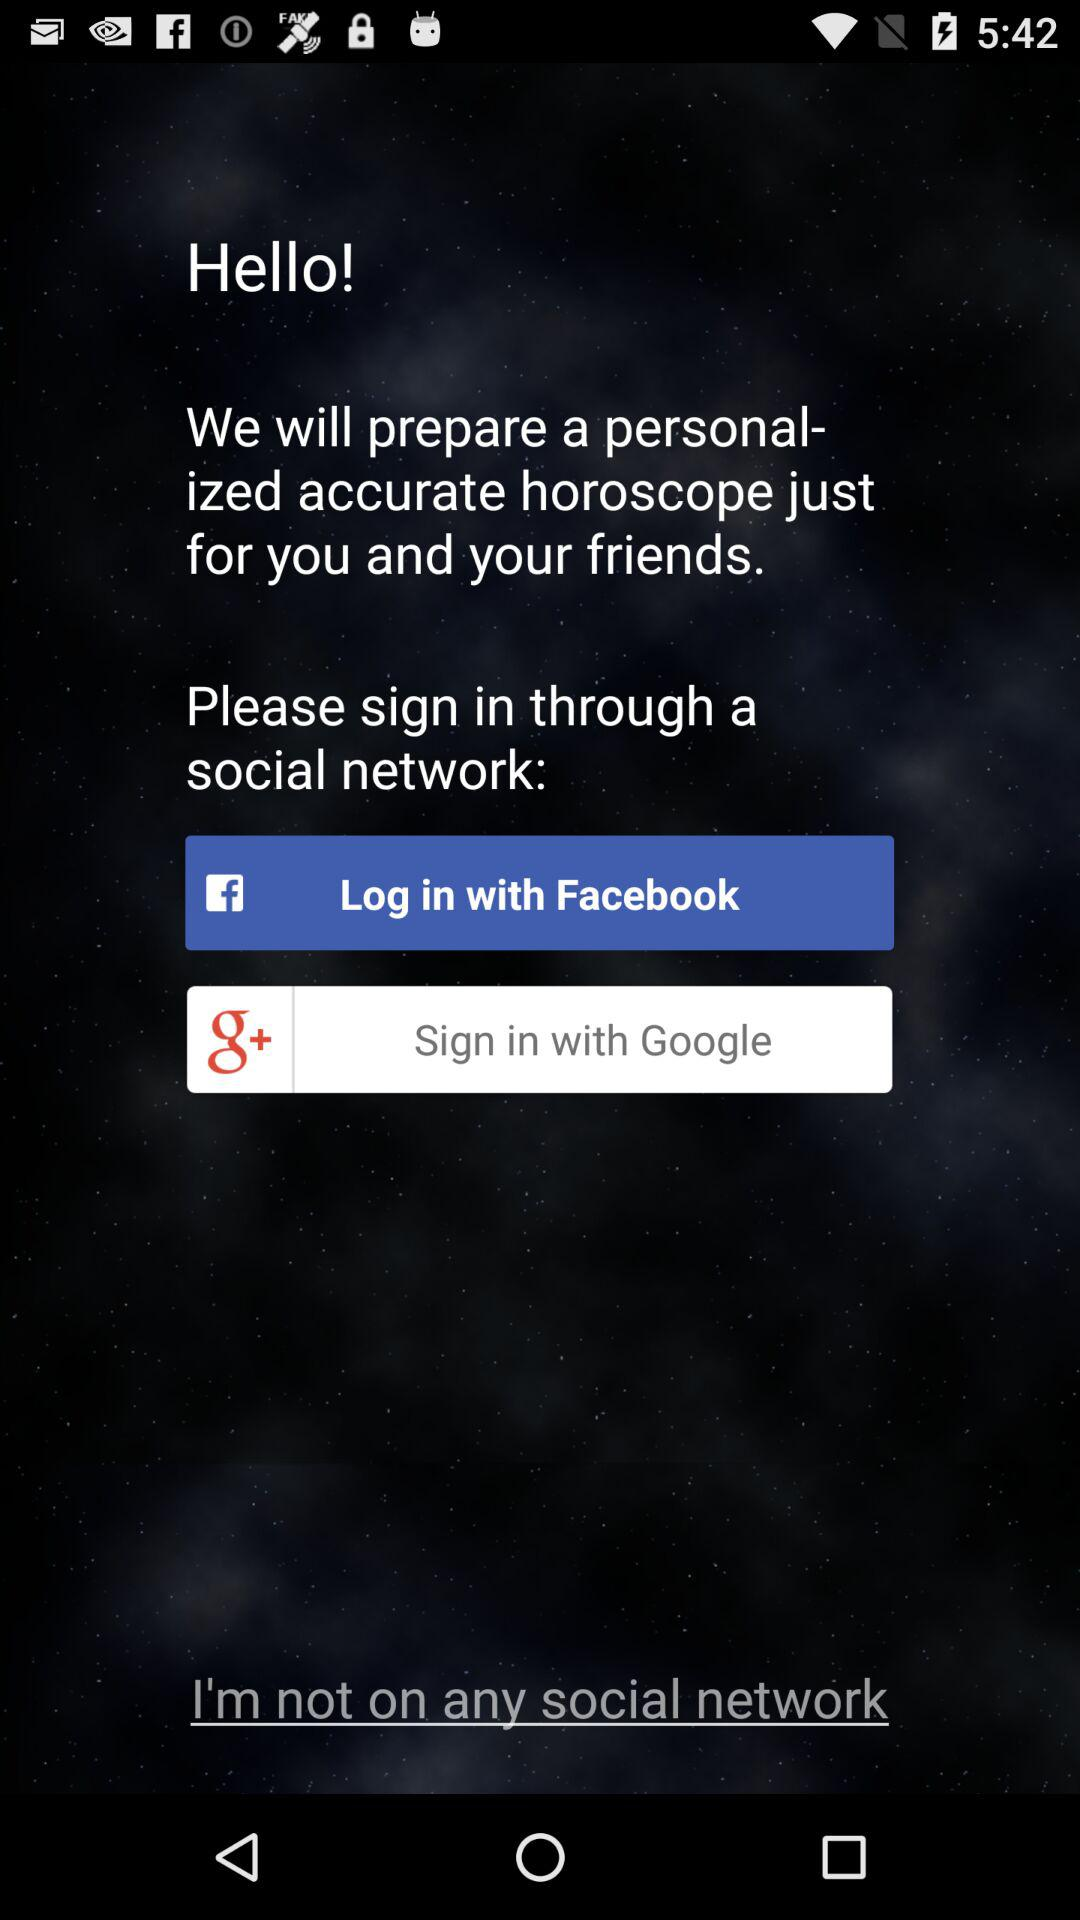How many social networks can I sign in with?
Answer the question using a single word or phrase. 2 